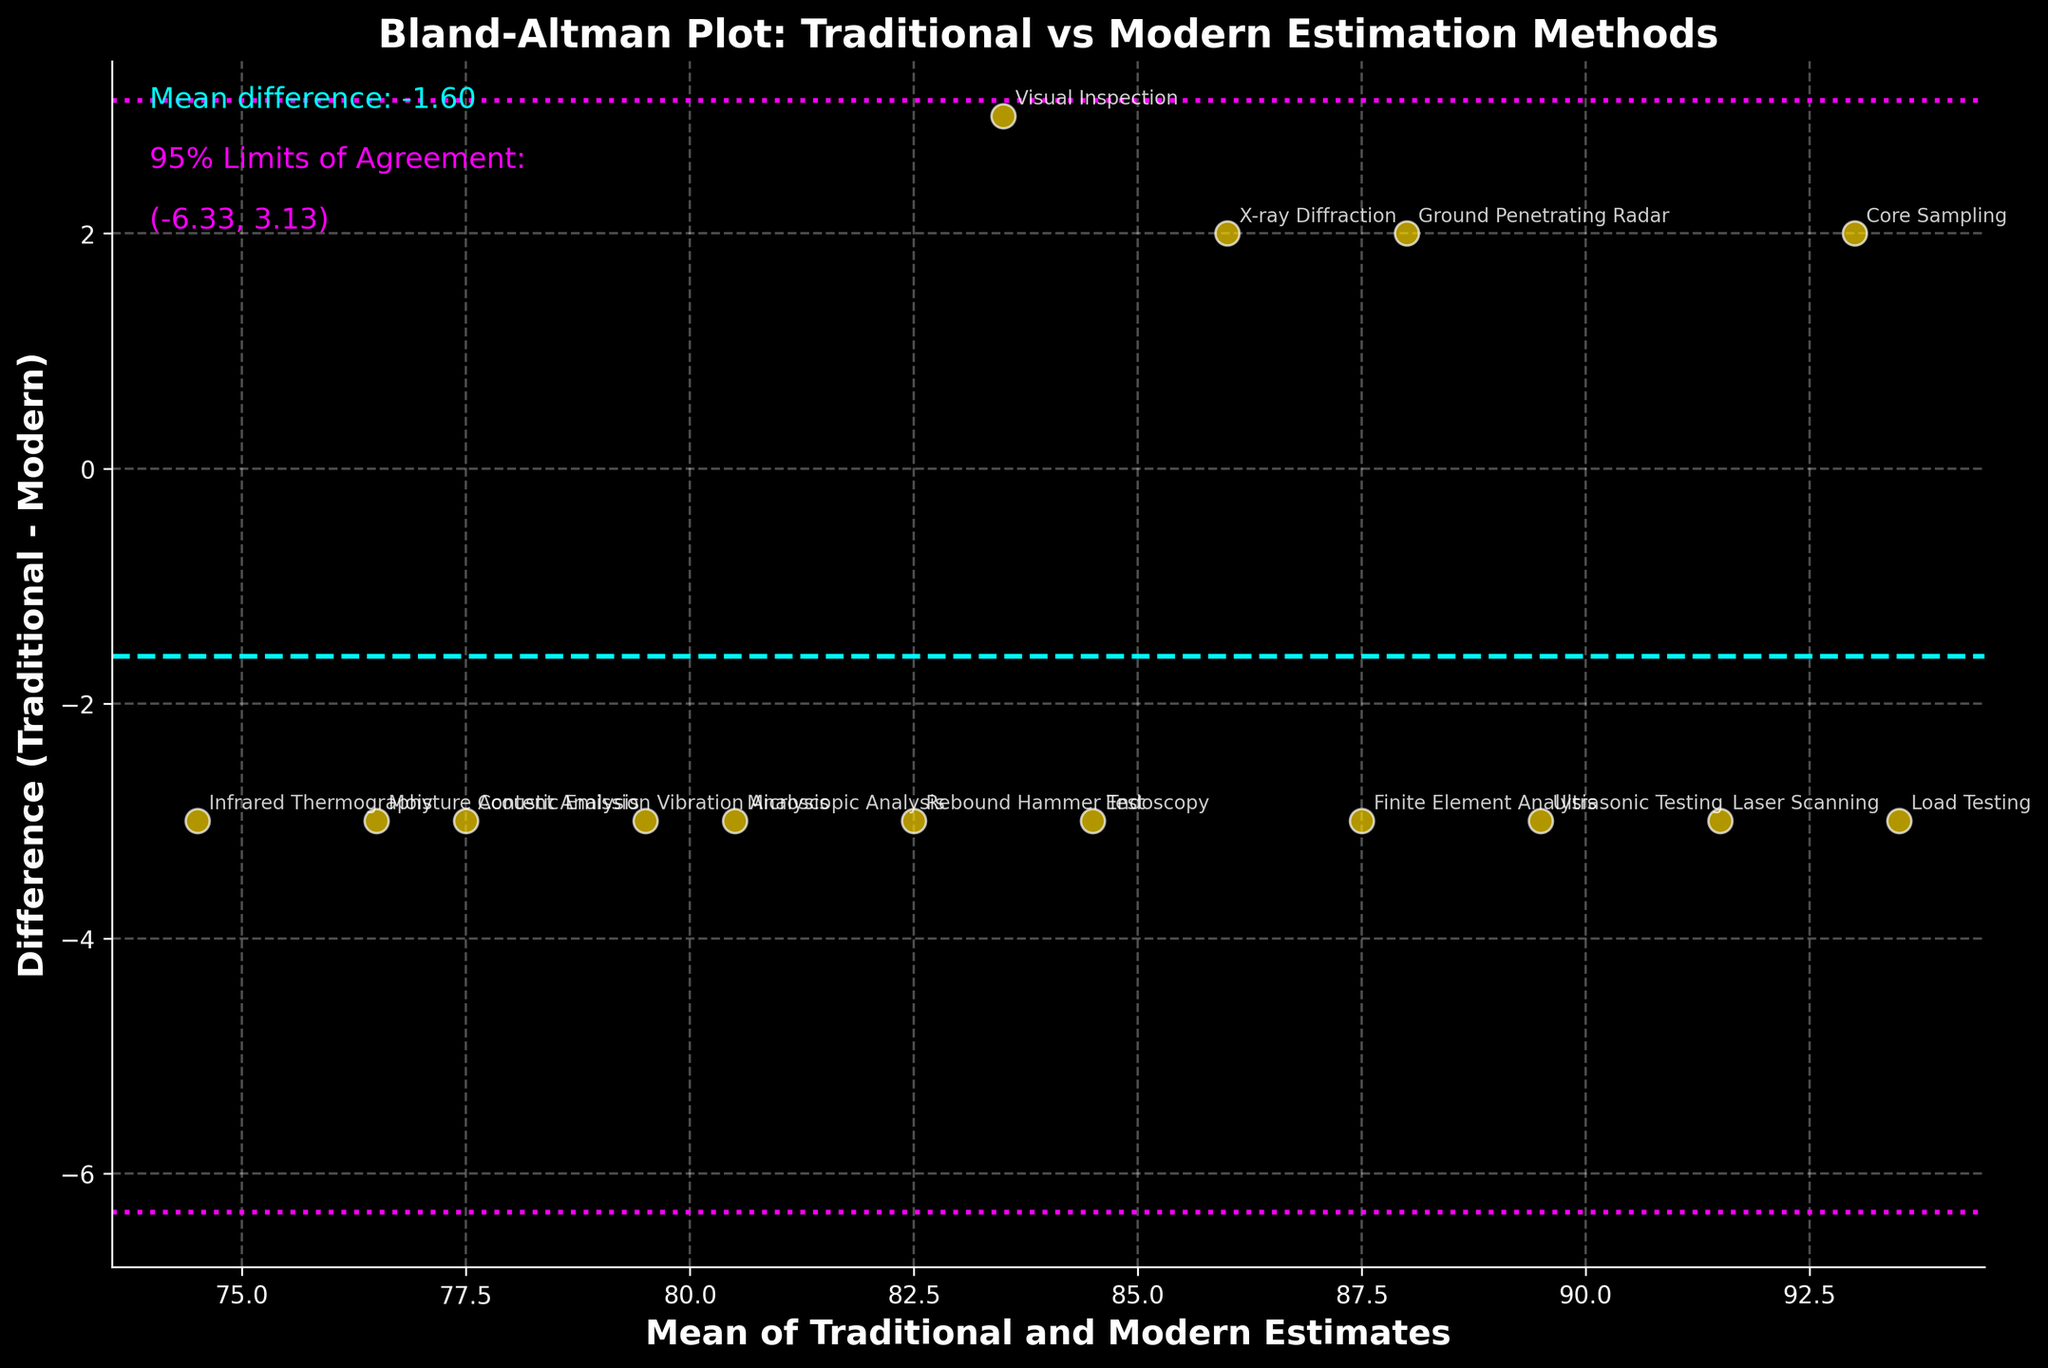What is the mean difference between traditional and modern estimation methods? Observe the cyan dashed horizontal line labeled as 'Mean difference' on the plot. The value is also mentioned in cyan text on the top left of the plot.
Answer: 1.67 What are the 95% limits of agreement? Observe the magenta dotted horizontal lines labeled as '95% Limits of Agreement' on the plot. The values are also mentioned in magenta text on the top left of the plot.
Answer: (-1.25, 4.58) How many data points are shown in the Bland-Altman plot? Count the number of gold scatter points in the figure. Each point represents a pairwise comparison between traditional and modern methods.
Answer: 15 Which method shows the largest difference between traditional and modern estimates? Look for the method with the maximum vertical distance from the horizontal line representing the mean difference. The labeled method name can be identified next to this point.
Answer: Load Testing Are there any methods where the traditional estimate is greater than the modern estimate? Identify points above the mean difference line (positive difference), read the adjacent method labels.
Answer: Yes, e.g., Visual Inspection, Ground Penetrating Radar What is the mean of traditional and modern estimates for Ultrasonic Testing? Identify the point labeled "Ultrasonic Testing" in the plot. Read the x-coordinate value (Mean of Traditional and Modern Estimates) corresponding to this point.
Answer: 89.5 Which methods fall outside the 95% limits of agreement? Identify points that lie beyond the magenta dotted lines and read the adjacent method labels.
Answer: None Is there a trend indicating bias in traditional estimates compared to modern ones? Observe if the differences consistently increase or decrease with the mean of estimates. The scattered points do not show a systematic pattern.
Answer: No clear trend What would be the implication if a method consistently lay outside the 95% limits of agreement? Such a method would indicate significant disagreement between traditional and modern estimates, suggesting potential inconsistency or bias in one of the methods.
Answer: Significant disagreement 